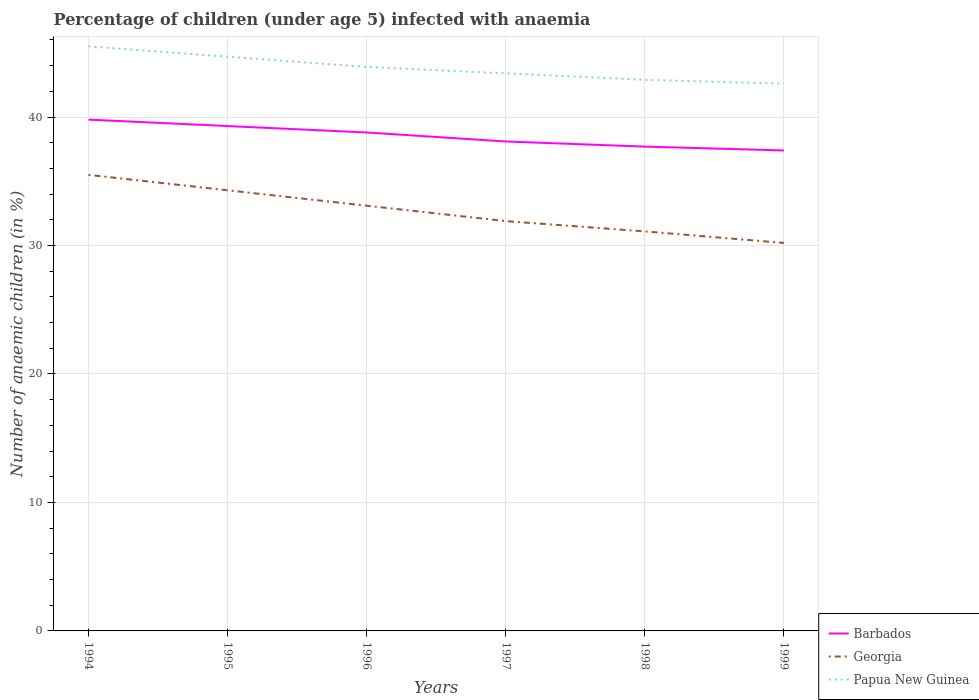Is the number of lines equal to the number of legend labels?
Your answer should be very brief. Yes. Across all years, what is the maximum percentage of children infected with anaemia in in Barbados?
Provide a succinct answer. 37.4. In which year was the percentage of children infected with anaemia in in Papua New Guinea maximum?
Provide a succinct answer. 1999. What is the total percentage of children infected with anaemia in in Barbados in the graph?
Keep it short and to the point. 1.4. What is the difference between the highest and the second highest percentage of children infected with anaemia in in Papua New Guinea?
Give a very brief answer. 2.9. What is the difference between the highest and the lowest percentage of children infected with anaemia in in Papua New Guinea?
Ensure brevity in your answer.  3. Is the percentage of children infected with anaemia in in Barbados strictly greater than the percentage of children infected with anaemia in in Georgia over the years?
Your answer should be compact. No. How many lines are there?
Offer a terse response. 3. How many years are there in the graph?
Ensure brevity in your answer.  6. Does the graph contain grids?
Offer a very short reply. Yes. How many legend labels are there?
Offer a terse response. 3. How are the legend labels stacked?
Make the answer very short. Vertical. What is the title of the graph?
Ensure brevity in your answer.  Percentage of children (under age 5) infected with anaemia. What is the label or title of the X-axis?
Provide a succinct answer. Years. What is the label or title of the Y-axis?
Make the answer very short. Number of anaemic children (in %). What is the Number of anaemic children (in %) of Barbados in 1994?
Provide a succinct answer. 39.8. What is the Number of anaemic children (in %) in Georgia in 1994?
Provide a succinct answer. 35.5. What is the Number of anaemic children (in %) in Papua New Guinea in 1994?
Provide a succinct answer. 45.5. What is the Number of anaemic children (in %) in Barbados in 1995?
Your answer should be very brief. 39.3. What is the Number of anaemic children (in %) of Georgia in 1995?
Make the answer very short. 34.3. What is the Number of anaemic children (in %) of Papua New Guinea in 1995?
Make the answer very short. 44.7. What is the Number of anaemic children (in %) of Barbados in 1996?
Provide a succinct answer. 38.8. What is the Number of anaemic children (in %) of Georgia in 1996?
Your answer should be very brief. 33.1. What is the Number of anaemic children (in %) of Papua New Guinea in 1996?
Offer a very short reply. 43.9. What is the Number of anaemic children (in %) in Barbados in 1997?
Offer a very short reply. 38.1. What is the Number of anaemic children (in %) in Georgia in 1997?
Your answer should be very brief. 31.9. What is the Number of anaemic children (in %) of Papua New Guinea in 1997?
Offer a very short reply. 43.4. What is the Number of anaemic children (in %) in Barbados in 1998?
Give a very brief answer. 37.7. What is the Number of anaemic children (in %) of Georgia in 1998?
Keep it short and to the point. 31.1. What is the Number of anaemic children (in %) in Papua New Guinea in 1998?
Your response must be concise. 42.9. What is the Number of anaemic children (in %) of Barbados in 1999?
Your answer should be compact. 37.4. What is the Number of anaemic children (in %) in Georgia in 1999?
Your answer should be compact. 30.2. What is the Number of anaemic children (in %) of Papua New Guinea in 1999?
Keep it short and to the point. 42.6. Across all years, what is the maximum Number of anaemic children (in %) of Barbados?
Keep it short and to the point. 39.8. Across all years, what is the maximum Number of anaemic children (in %) of Georgia?
Give a very brief answer. 35.5. Across all years, what is the maximum Number of anaemic children (in %) in Papua New Guinea?
Provide a succinct answer. 45.5. Across all years, what is the minimum Number of anaemic children (in %) of Barbados?
Your response must be concise. 37.4. Across all years, what is the minimum Number of anaemic children (in %) in Georgia?
Your answer should be very brief. 30.2. Across all years, what is the minimum Number of anaemic children (in %) in Papua New Guinea?
Provide a succinct answer. 42.6. What is the total Number of anaemic children (in %) of Barbados in the graph?
Your response must be concise. 231.1. What is the total Number of anaemic children (in %) of Georgia in the graph?
Your response must be concise. 196.1. What is the total Number of anaemic children (in %) of Papua New Guinea in the graph?
Ensure brevity in your answer.  263. What is the difference between the Number of anaemic children (in %) in Georgia in 1994 and that in 1995?
Provide a short and direct response. 1.2. What is the difference between the Number of anaemic children (in %) in Papua New Guinea in 1994 and that in 1995?
Your response must be concise. 0.8. What is the difference between the Number of anaemic children (in %) of Barbados in 1994 and that in 1996?
Offer a terse response. 1. What is the difference between the Number of anaemic children (in %) in Georgia in 1994 and that in 1998?
Provide a succinct answer. 4.4. What is the difference between the Number of anaemic children (in %) in Papua New Guinea in 1994 and that in 1998?
Provide a succinct answer. 2.6. What is the difference between the Number of anaemic children (in %) of Barbados in 1994 and that in 1999?
Make the answer very short. 2.4. What is the difference between the Number of anaemic children (in %) in Barbados in 1995 and that in 1996?
Ensure brevity in your answer.  0.5. What is the difference between the Number of anaemic children (in %) in Georgia in 1995 and that in 1996?
Your answer should be compact. 1.2. What is the difference between the Number of anaemic children (in %) in Papua New Guinea in 1995 and that in 1996?
Provide a succinct answer. 0.8. What is the difference between the Number of anaemic children (in %) of Barbados in 1995 and that in 1997?
Offer a very short reply. 1.2. What is the difference between the Number of anaemic children (in %) of Georgia in 1995 and that in 1997?
Your answer should be very brief. 2.4. What is the difference between the Number of anaemic children (in %) of Papua New Guinea in 1995 and that in 1997?
Your response must be concise. 1.3. What is the difference between the Number of anaemic children (in %) of Barbados in 1995 and that in 1998?
Make the answer very short. 1.6. What is the difference between the Number of anaemic children (in %) in Papua New Guinea in 1995 and that in 1998?
Keep it short and to the point. 1.8. What is the difference between the Number of anaemic children (in %) of Barbados in 1995 and that in 1999?
Keep it short and to the point. 1.9. What is the difference between the Number of anaemic children (in %) in Georgia in 1995 and that in 1999?
Your response must be concise. 4.1. What is the difference between the Number of anaemic children (in %) in Barbados in 1996 and that in 1997?
Make the answer very short. 0.7. What is the difference between the Number of anaemic children (in %) in Georgia in 1996 and that in 1997?
Offer a very short reply. 1.2. What is the difference between the Number of anaemic children (in %) in Georgia in 1996 and that in 1998?
Offer a terse response. 2. What is the difference between the Number of anaemic children (in %) in Barbados in 1997 and that in 1998?
Give a very brief answer. 0.4. What is the difference between the Number of anaemic children (in %) of Georgia in 1997 and that in 1998?
Provide a short and direct response. 0.8. What is the difference between the Number of anaemic children (in %) in Papua New Guinea in 1997 and that in 1999?
Offer a terse response. 0.8. What is the difference between the Number of anaemic children (in %) of Barbados in 1994 and the Number of anaemic children (in %) of Papua New Guinea in 1995?
Your answer should be compact. -4.9. What is the difference between the Number of anaemic children (in %) in Barbados in 1994 and the Number of anaemic children (in %) in Papua New Guinea in 1996?
Offer a terse response. -4.1. What is the difference between the Number of anaemic children (in %) in Barbados in 1994 and the Number of anaemic children (in %) in Georgia in 1999?
Keep it short and to the point. 9.6. What is the difference between the Number of anaemic children (in %) of Georgia in 1994 and the Number of anaemic children (in %) of Papua New Guinea in 1999?
Provide a succinct answer. -7.1. What is the difference between the Number of anaemic children (in %) of Barbados in 1995 and the Number of anaemic children (in %) of Papua New Guinea in 1996?
Make the answer very short. -4.6. What is the difference between the Number of anaemic children (in %) in Barbados in 1995 and the Number of anaemic children (in %) in Georgia in 1997?
Offer a very short reply. 7.4. What is the difference between the Number of anaemic children (in %) in Georgia in 1995 and the Number of anaemic children (in %) in Papua New Guinea in 1997?
Offer a very short reply. -9.1. What is the difference between the Number of anaemic children (in %) in Barbados in 1995 and the Number of anaemic children (in %) in Georgia in 1998?
Make the answer very short. 8.2. What is the difference between the Number of anaemic children (in %) in Georgia in 1995 and the Number of anaemic children (in %) in Papua New Guinea in 1999?
Provide a succinct answer. -8.3. What is the difference between the Number of anaemic children (in %) of Georgia in 1996 and the Number of anaemic children (in %) of Papua New Guinea in 1997?
Ensure brevity in your answer.  -10.3. What is the difference between the Number of anaemic children (in %) of Barbados in 1996 and the Number of anaemic children (in %) of Georgia in 1998?
Keep it short and to the point. 7.7. What is the difference between the Number of anaemic children (in %) of Barbados in 1996 and the Number of anaemic children (in %) of Papua New Guinea in 1999?
Give a very brief answer. -3.8. What is the difference between the Number of anaemic children (in %) in Georgia in 1996 and the Number of anaemic children (in %) in Papua New Guinea in 1999?
Your response must be concise. -9.5. What is the difference between the Number of anaemic children (in %) of Barbados in 1997 and the Number of anaemic children (in %) of Georgia in 1998?
Your response must be concise. 7. What is the difference between the Number of anaemic children (in %) of Georgia in 1997 and the Number of anaemic children (in %) of Papua New Guinea in 1998?
Your response must be concise. -11. What is the difference between the Number of anaemic children (in %) in Barbados in 1997 and the Number of anaemic children (in %) in Papua New Guinea in 1999?
Keep it short and to the point. -4.5. What is the difference between the Number of anaemic children (in %) of Georgia in 1997 and the Number of anaemic children (in %) of Papua New Guinea in 1999?
Provide a short and direct response. -10.7. What is the difference between the Number of anaemic children (in %) in Georgia in 1998 and the Number of anaemic children (in %) in Papua New Guinea in 1999?
Ensure brevity in your answer.  -11.5. What is the average Number of anaemic children (in %) in Barbados per year?
Ensure brevity in your answer.  38.52. What is the average Number of anaemic children (in %) of Georgia per year?
Offer a very short reply. 32.68. What is the average Number of anaemic children (in %) of Papua New Guinea per year?
Offer a very short reply. 43.83. In the year 1994, what is the difference between the Number of anaemic children (in %) of Barbados and Number of anaemic children (in %) of Georgia?
Ensure brevity in your answer.  4.3. In the year 1995, what is the difference between the Number of anaemic children (in %) in Barbados and Number of anaemic children (in %) in Papua New Guinea?
Your response must be concise. -5.4. In the year 1998, what is the difference between the Number of anaemic children (in %) of Georgia and Number of anaemic children (in %) of Papua New Guinea?
Make the answer very short. -11.8. In the year 1999, what is the difference between the Number of anaemic children (in %) in Barbados and Number of anaemic children (in %) in Georgia?
Provide a short and direct response. 7.2. What is the ratio of the Number of anaemic children (in %) in Barbados in 1994 to that in 1995?
Offer a very short reply. 1.01. What is the ratio of the Number of anaemic children (in %) in Georgia in 1994 to that in 1995?
Your response must be concise. 1.03. What is the ratio of the Number of anaemic children (in %) of Papua New Guinea in 1994 to that in 1995?
Offer a very short reply. 1.02. What is the ratio of the Number of anaemic children (in %) in Barbados in 1994 to that in 1996?
Your response must be concise. 1.03. What is the ratio of the Number of anaemic children (in %) of Georgia in 1994 to that in 1996?
Your answer should be compact. 1.07. What is the ratio of the Number of anaemic children (in %) of Papua New Guinea in 1994 to that in 1996?
Ensure brevity in your answer.  1.04. What is the ratio of the Number of anaemic children (in %) in Barbados in 1994 to that in 1997?
Provide a short and direct response. 1.04. What is the ratio of the Number of anaemic children (in %) in Georgia in 1994 to that in 1997?
Provide a succinct answer. 1.11. What is the ratio of the Number of anaemic children (in %) of Papua New Guinea in 1994 to that in 1997?
Your answer should be very brief. 1.05. What is the ratio of the Number of anaemic children (in %) in Barbados in 1994 to that in 1998?
Give a very brief answer. 1.06. What is the ratio of the Number of anaemic children (in %) in Georgia in 1994 to that in 1998?
Provide a succinct answer. 1.14. What is the ratio of the Number of anaemic children (in %) of Papua New Guinea in 1994 to that in 1998?
Give a very brief answer. 1.06. What is the ratio of the Number of anaemic children (in %) in Barbados in 1994 to that in 1999?
Offer a terse response. 1.06. What is the ratio of the Number of anaemic children (in %) of Georgia in 1994 to that in 1999?
Your answer should be very brief. 1.18. What is the ratio of the Number of anaemic children (in %) in Papua New Guinea in 1994 to that in 1999?
Offer a very short reply. 1.07. What is the ratio of the Number of anaemic children (in %) of Barbados in 1995 to that in 1996?
Your response must be concise. 1.01. What is the ratio of the Number of anaemic children (in %) of Georgia in 1995 to that in 1996?
Your response must be concise. 1.04. What is the ratio of the Number of anaemic children (in %) in Papua New Guinea in 1995 to that in 1996?
Keep it short and to the point. 1.02. What is the ratio of the Number of anaemic children (in %) in Barbados in 1995 to that in 1997?
Keep it short and to the point. 1.03. What is the ratio of the Number of anaemic children (in %) of Georgia in 1995 to that in 1997?
Give a very brief answer. 1.08. What is the ratio of the Number of anaemic children (in %) in Papua New Guinea in 1995 to that in 1997?
Give a very brief answer. 1.03. What is the ratio of the Number of anaemic children (in %) in Barbados in 1995 to that in 1998?
Your answer should be very brief. 1.04. What is the ratio of the Number of anaemic children (in %) in Georgia in 1995 to that in 1998?
Offer a terse response. 1.1. What is the ratio of the Number of anaemic children (in %) of Papua New Guinea in 1995 to that in 1998?
Keep it short and to the point. 1.04. What is the ratio of the Number of anaemic children (in %) of Barbados in 1995 to that in 1999?
Provide a succinct answer. 1.05. What is the ratio of the Number of anaemic children (in %) of Georgia in 1995 to that in 1999?
Your response must be concise. 1.14. What is the ratio of the Number of anaemic children (in %) in Papua New Guinea in 1995 to that in 1999?
Your answer should be compact. 1.05. What is the ratio of the Number of anaemic children (in %) of Barbados in 1996 to that in 1997?
Ensure brevity in your answer.  1.02. What is the ratio of the Number of anaemic children (in %) in Georgia in 1996 to that in 1997?
Give a very brief answer. 1.04. What is the ratio of the Number of anaemic children (in %) in Papua New Guinea in 1996 to that in 1997?
Your response must be concise. 1.01. What is the ratio of the Number of anaemic children (in %) of Barbados in 1996 to that in 1998?
Your answer should be compact. 1.03. What is the ratio of the Number of anaemic children (in %) of Georgia in 1996 to that in 1998?
Offer a very short reply. 1.06. What is the ratio of the Number of anaemic children (in %) in Papua New Guinea in 1996 to that in 1998?
Your answer should be compact. 1.02. What is the ratio of the Number of anaemic children (in %) in Barbados in 1996 to that in 1999?
Give a very brief answer. 1.04. What is the ratio of the Number of anaemic children (in %) of Georgia in 1996 to that in 1999?
Your answer should be compact. 1.1. What is the ratio of the Number of anaemic children (in %) in Papua New Guinea in 1996 to that in 1999?
Provide a short and direct response. 1.03. What is the ratio of the Number of anaemic children (in %) of Barbados in 1997 to that in 1998?
Your answer should be very brief. 1.01. What is the ratio of the Number of anaemic children (in %) of Georgia in 1997 to that in 1998?
Your answer should be compact. 1.03. What is the ratio of the Number of anaemic children (in %) in Papua New Guinea in 1997 to that in 1998?
Your answer should be very brief. 1.01. What is the ratio of the Number of anaemic children (in %) in Barbados in 1997 to that in 1999?
Provide a succinct answer. 1.02. What is the ratio of the Number of anaemic children (in %) in Georgia in 1997 to that in 1999?
Ensure brevity in your answer.  1.06. What is the ratio of the Number of anaemic children (in %) of Papua New Guinea in 1997 to that in 1999?
Provide a succinct answer. 1.02. What is the ratio of the Number of anaemic children (in %) of Barbados in 1998 to that in 1999?
Make the answer very short. 1.01. What is the ratio of the Number of anaemic children (in %) in Georgia in 1998 to that in 1999?
Your response must be concise. 1.03. What is the ratio of the Number of anaemic children (in %) in Papua New Guinea in 1998 to that in 1999?
Give a very brief answer. 1.01. What is the difference between the highest and the second highest Number of anaemic children (in %) of Barbados?
Your answer should be compact. 0.5. What is the difference between the highest and the second highest Number of anaemic children (in %) in Georgia?
Make the answer very short. 1.2. What is the difference between the highest and the second highest Number of anaemic children (in %) in Papua New Guinea?
Give a very brief answer. 0.8. What is the difference between the highest and the lowest Number of anaemic children (in %) in Barbados?
Provide a short and direct response. 2.4. 